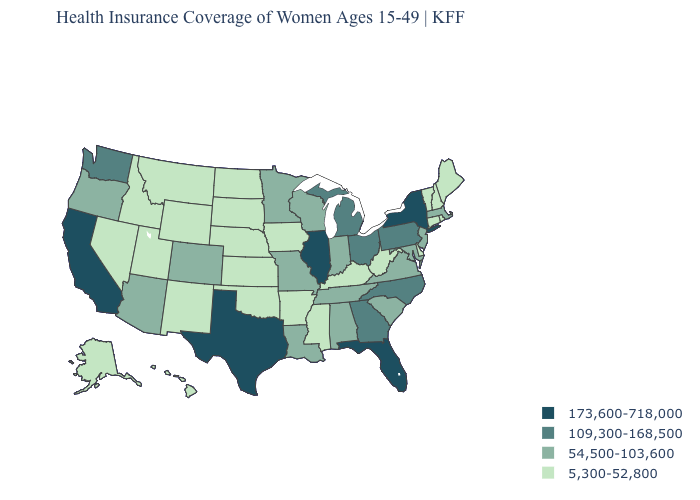What is the value of Texas?
Be succinct. 173,600-718,000. What is the lowest value in the USA?
Give a very brief answer. 5,300-52,800. What is the value of Wyoming?
Give a very brief answer. 5,300-52,800. Does the map have missing data?
Write a very short answer. No. What is the lowest value in the USA?
Short answer required. 5,300-52,800. What is the highest value in the MidWest ?
Give a very brief answer. 173,600-718,000. What is the value of South Carolina?
Concise answer only. 54,500-103,600. What is the value of Alaska?
Be succinct. 5,300-52,800. What is the value of North Dakota?
Keep it brief. 5,300-52,800. Among the states that border Ohio , does Pennsylvania have the highest value?
Short answer required. Yes. Name the states that have a value in the range 54,500-103,600?
Keep it brief. Alabama, Arizona, Colorado, Indiana, Louisiana, Maryland, Massachusetts, Minnesota, Missouri, New Jersey, Oregon, South Carolina, Tennessee, Virginia, Wisconsin. Does Missouri have a lower value than Wisconsin?
Write a very short answer. No. Does the map have missing data?
Be succinct. No. What is the highest value in the MidWest ?
Give a very brief answer. 173,600-718,000. Among the states that border Wyoming , which have the highest value?
Short answer required. Colorado. 